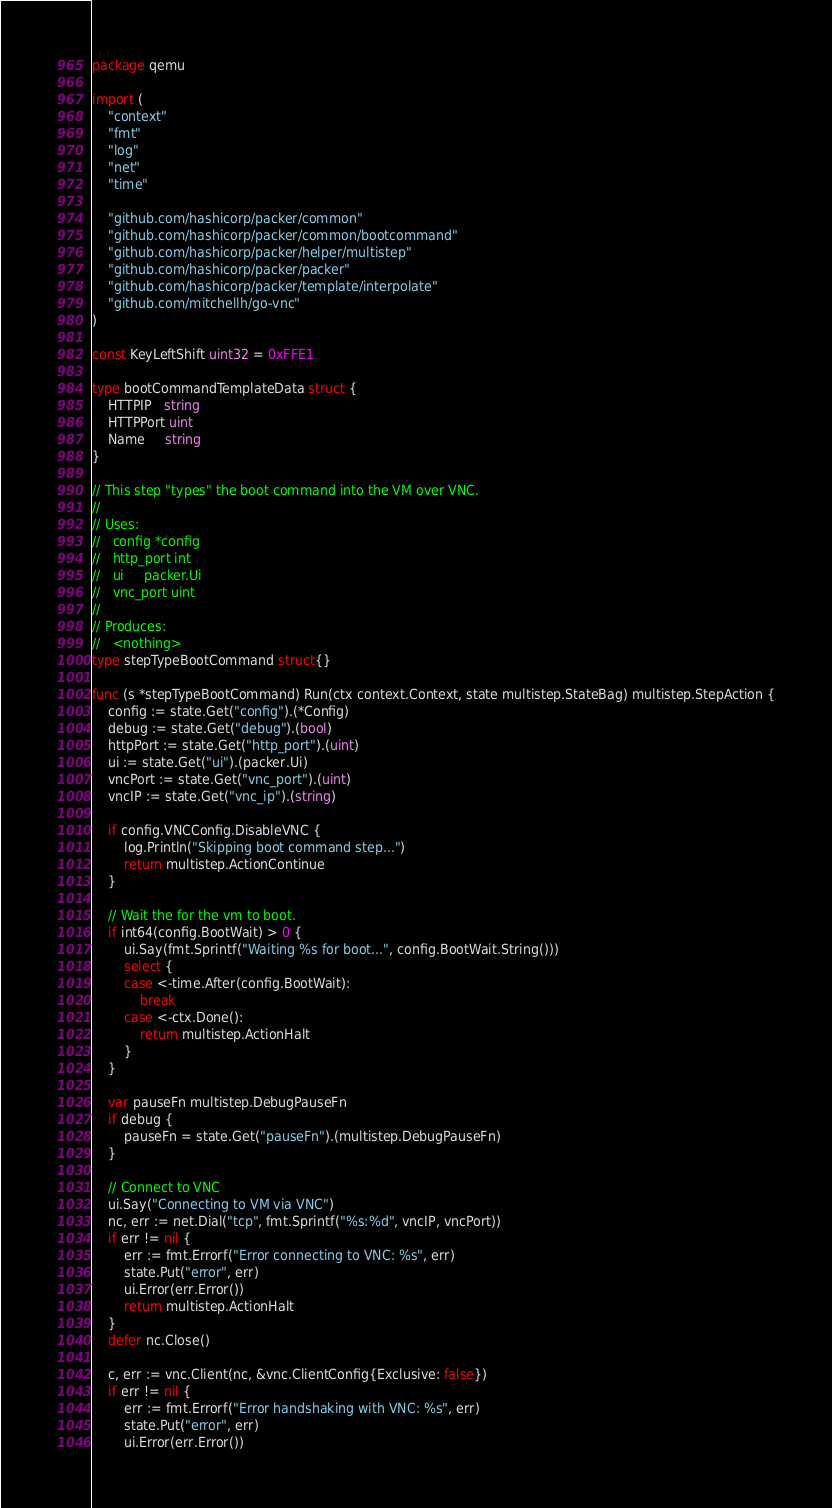<code> <loc_0><loc_0><loc_500><loc_500><_Go_>package qemu

import (
	"context"
	"fmt"
	"log"
	"net"
	"time"

	"github.com/hashicorp/packer/common"
	"github.com/hashicorp/packer/common/bootcommand"
	"github.com/hashicorp/packer/helper/multistep"
	"github.com/hashicorp/packer/packer"
	"github.com/hashicorp/packer/template/interpolate"
	"github.com/mitchellh/go-vnc"
)

const KeyLeftShift uint32 = 0xFFE1

type bootCommandTemplateData struct {
	HTTPIP   string
	HTTPPort uint
	Name     string
}

// This step "types" the boot command into the VM over VNC.
//
// Uses:
//   config *config
//   http_port int
//   ui     packer.Ui
//   vnc_port uint
//
// Produces:
//   <nothing>
type stepTypeBootCommand struct{}

func (s *stepTypeBootCommand) Run(ctx context.Context, state multistep.StateBag) multistep.StepAction {
	config := state.Get("config").(*Config)
	debug := state.Get("debug").(bool)
	httpPort := state.Get("http_port").(uint)
	ui := state.Get("ui").(packer.Ui)
	vncPort := state.Get("vnc_port").(uint)
	vncIP := state.Get("vnc_ip").(string)

	if config.VNCConfig.DisableVNC {
		log.Println("Skipping boot command step...")
		return multistep.ActionContinue
	}

	// Wait the for the vm to boot.
	if int64(config.BootWait) > 0 {
		ui.Say(fmt.Sprintf("Waiting %s for boot...", config.BootWait.String()))
		select {
		case <-time.After(config.BootWait):
			break
		case <-ctx.Done():
			return multistep.ActionHalt
		}
	}

	var pauseFn multistep.DebugPauseFn
	if debug {
		pauseFn = state.Get("pauseFn").(multistep.DebugPauseFn)
	}

	// Connect to VNC
	ui.Say("Connecting to VM via VNC")
	nc, err := net.Dial("tcp", fmt.Sprintf("%s:%d", vncIP, vncPort))
	if err != nil {
		err := fmt.Errorf("Error connecting to VNC: %s", err)
		state.Put("error", err)
		ui.Error(err.Error())
		return multistep.ActionHalt
	}
	defer nc.Close()

	c, err := vnc.Client(nc, &vnc.ClientConfig{Exclusive: false})
	if err != nil {
		err := fmt.Errorf("Error handshaking with VNC: %s", err)
		state.Put("error", err)
		ui.Error(err.Error())</code> 